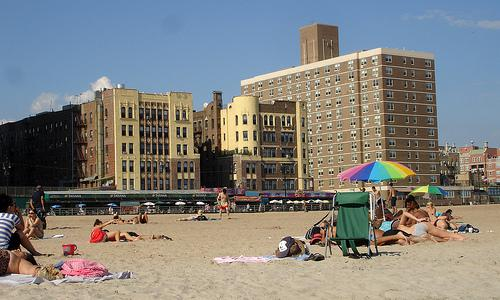Question: what color is the chair?
Choices:
A. Red.
B. Brown.
C. Blue.
D. Green.
Answer with the letter. Answer: D Question: when was this picture taken?
Choices:
A. At night.
B. While it was raining.
C. During the day.
D. During a snow storm.
Answer with the letter. Answer: C Question: what color are the umbrellas?
Choices:
A. Green.
B. Red.
C. Rainbow.
D. Blue.
Answer with the letter. Answer: C Question: why are people under the umbrellas?
Choices:
A. To stay out of the rain.
B. To stay cool.
C. There are no people under the umbrellas.
D. For shade.
Answer with the letter. Answer: D Question: where was this picture taken?
Choices:
A. The park.
B. The livingroom.
C. The beach.
D. The backyard.
Answer with the letter. Answer: C Question: how many umbrellas are there?
Choices:
A. Two.
B. One.
C. Three.
D. Four.
Answer with the letter. Answer: A Question: what is the beach covered in?
Choices:
A. People.
B. Sand.
C. Pebbles.
D. Birds.
Answer with the letter. Answer: B 